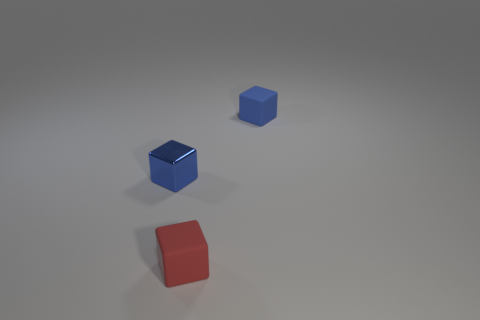Subtract all blue blocks. How many blocks are left? 1 Subtract all cyan spheres. How many blue cubes are left? 2 Subtract all red blocks. How many blocks are left? 2 Add 1 blue matte objects. How many objects exist? 4 Subtract 3 cubes. How many cubes are left? 0 Subtract all brown cubes. Subtract all yellow spheres. How many cubes are left? 3 Subtract all blue metal cubes. Subtract all small blue shiny cubes. How many objects are left? 1 Add 2 blue shiny things. How many blue shiny things are left? 3 Add 3 small blue objects. How many small blue objects exist? 5 Subtract 0 green balls. How many objects are left? 3 